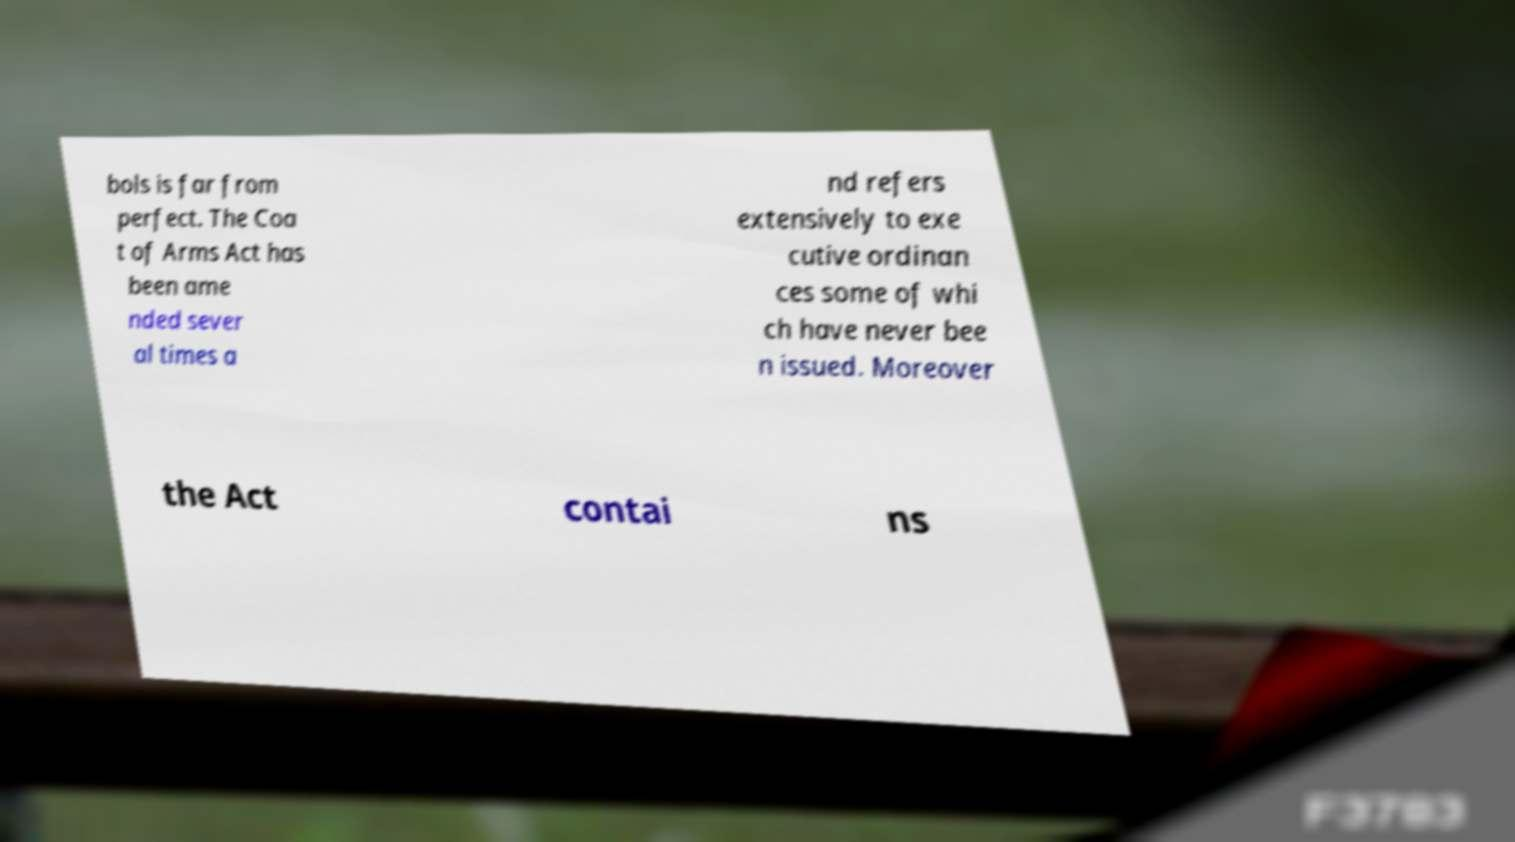Please read and relay the text visible in this image. What does it say? bols is far from perfect. The Coa t of Arms Act has been ame nded sever al times a nd refers extensively to exe cutive ordinan ces some of whi ch have never bee n issued. Moreover the Act contai ns 